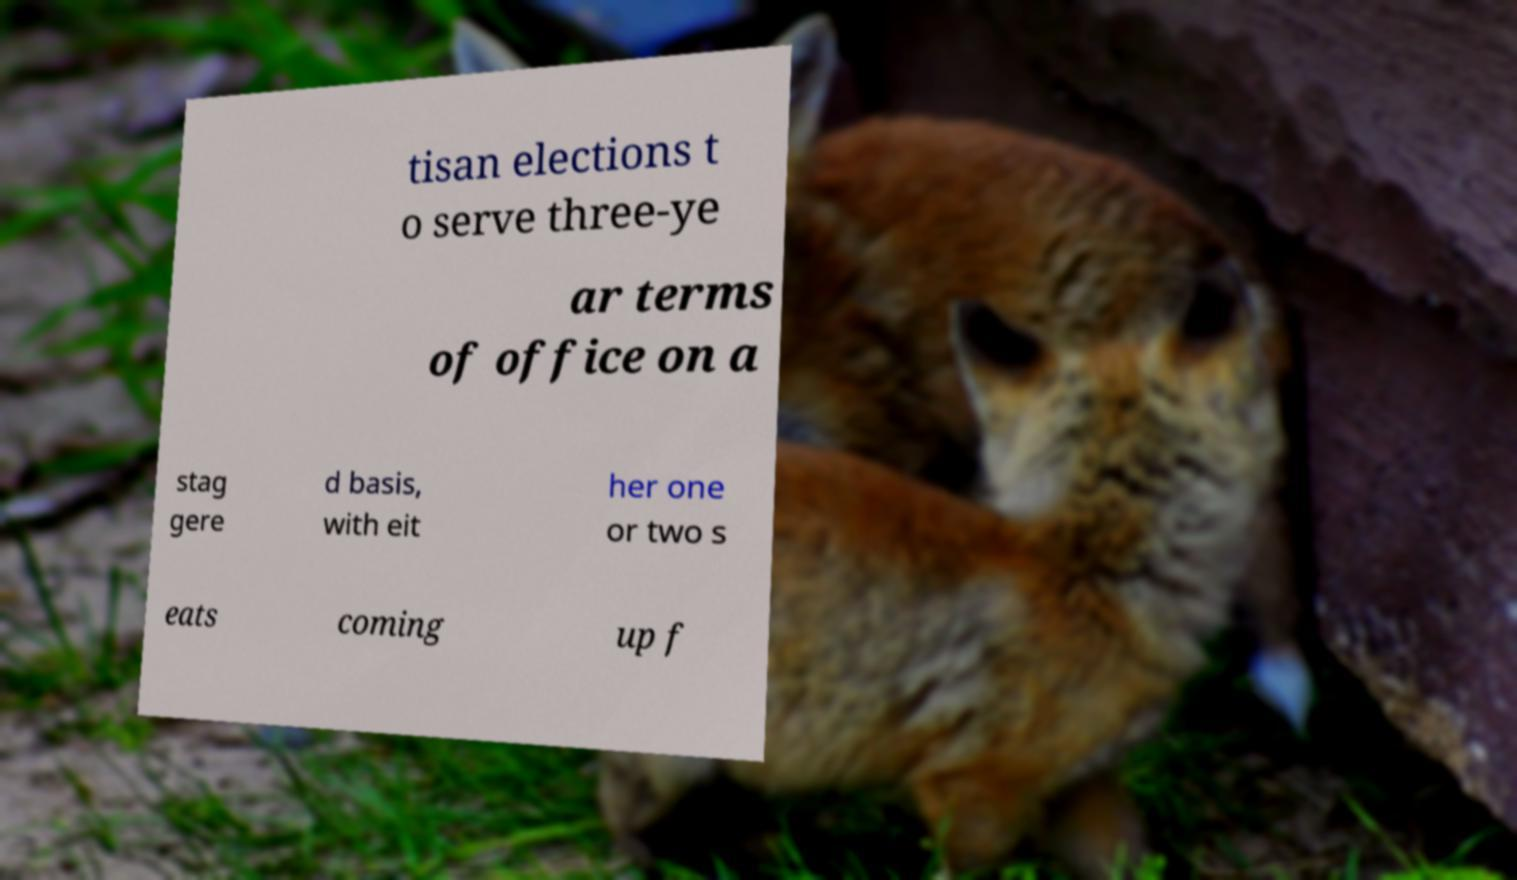Please identify and transcribe the text found in this image. tisan elections t o serve three-ye ar terms of office on a stag gere d basis, with eit her one or two s eats coming up f 